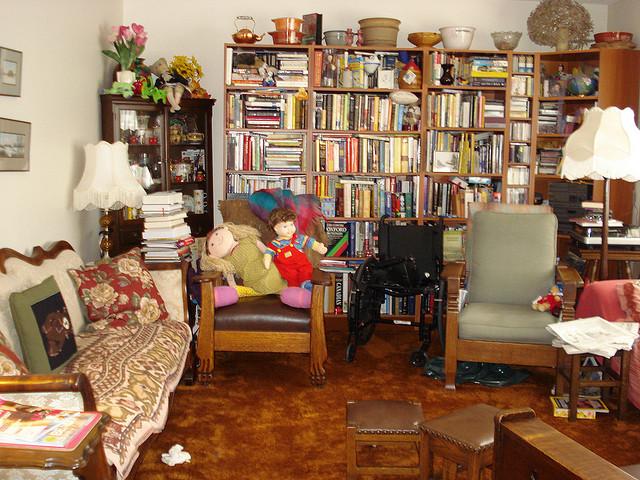What kind of room is this?
Be succinct. Living room. How many lamps shades are there?
Quick response, please. 2. What is the floor made of?
Answer briefly. Carpet. What kind of doll is in red?
Be succinct. Cabbage patch kid. 